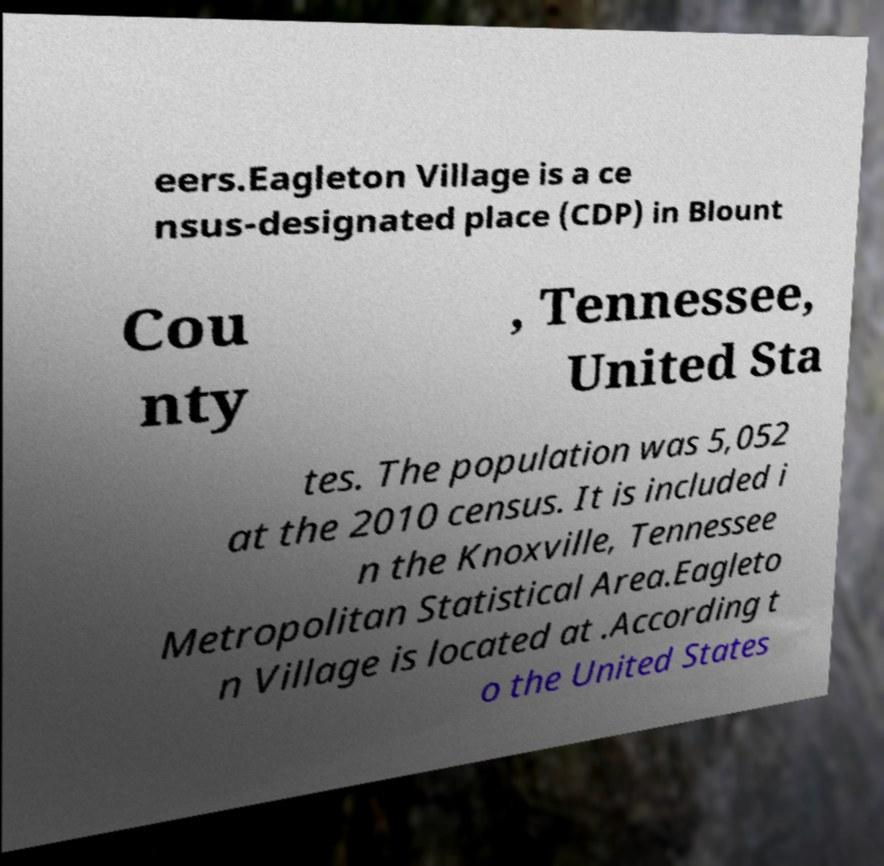Please read and relay the text visible in this image. What does it say? eers.Eagleton Village is a ce nsus-designated place (CDP) in Blount Cou nty , Tennessee, United Sta tes. The population was 5,052 at the 2010 census. It is included i n the Knoxville, Tennessee Metropolitan Statistical Area.Eagleto n Village is located at .According t o the United States 